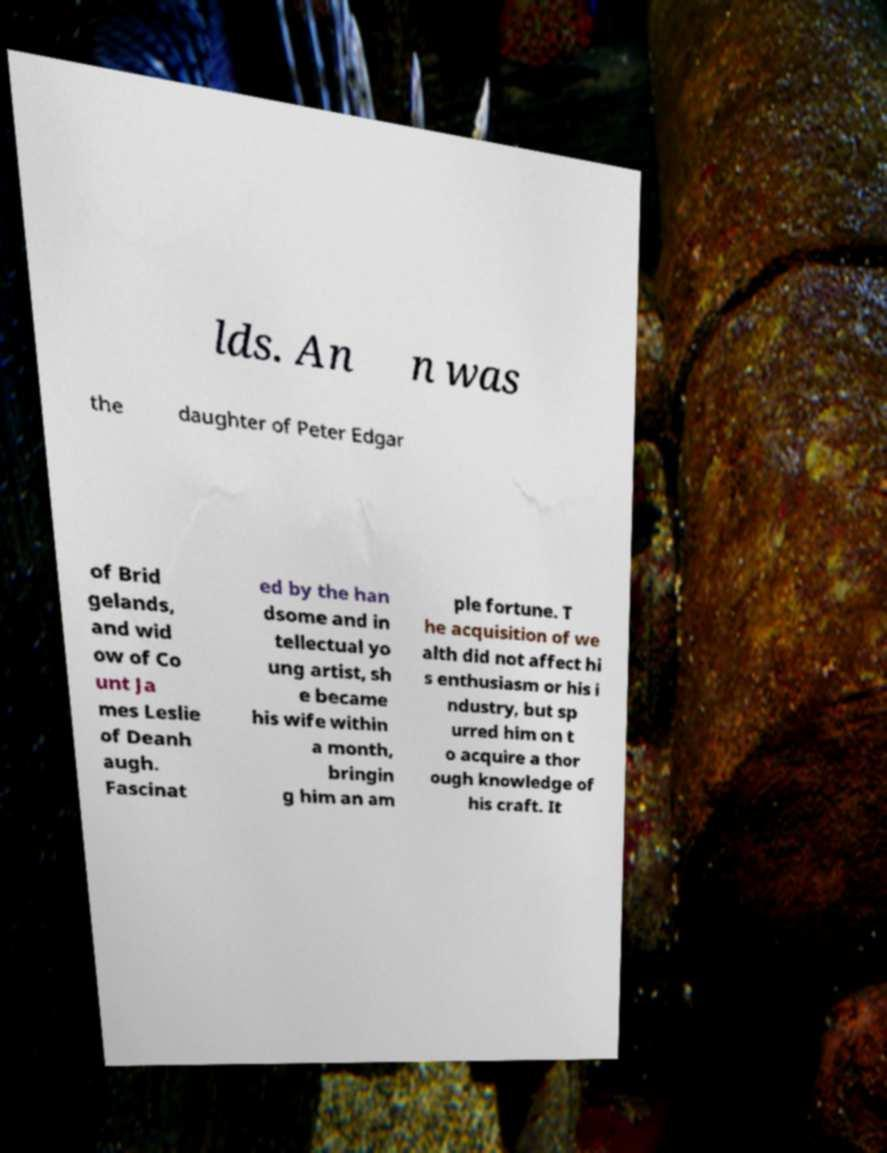For documentation purposes, I need the text within this image transcribed. Could you provide that? lds. An n was the daughter of Peter Edgar of Brid gelands, and wid ow of Co unt Ja mes Leslie of Deanh augh. Fascinat ed by the han dsome and in tellectual yo ung artist, sh e became his wife within a month, bringin g him an am ple fortune. T he acquisition of we alth did not affect hi s enthusiasm or his i ndustry, but sp urred him on t o acquire a thor ough knowledge of his craft. It 